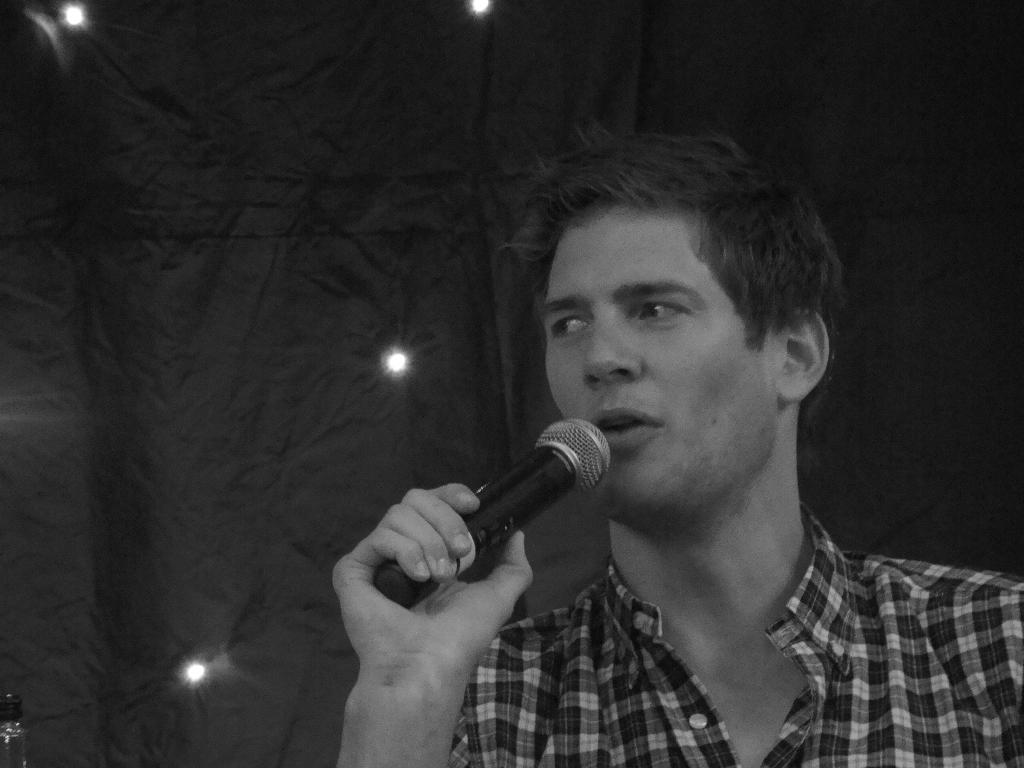What is the main subject of the image? There is a person in the image. What is the person holding in the image? The person is holding a microphone. What type of clothing is the person wearing? The person is wearing a shirt. What can be seen in the background of the image? There is a curtain in the background of the image. What else is visible in the image? There are lights visible in the image. How many girls are playing in the town depicted in the image? There are no girls or town present in the image; it features a person holding a microphone with a curtain and lights in the background. 